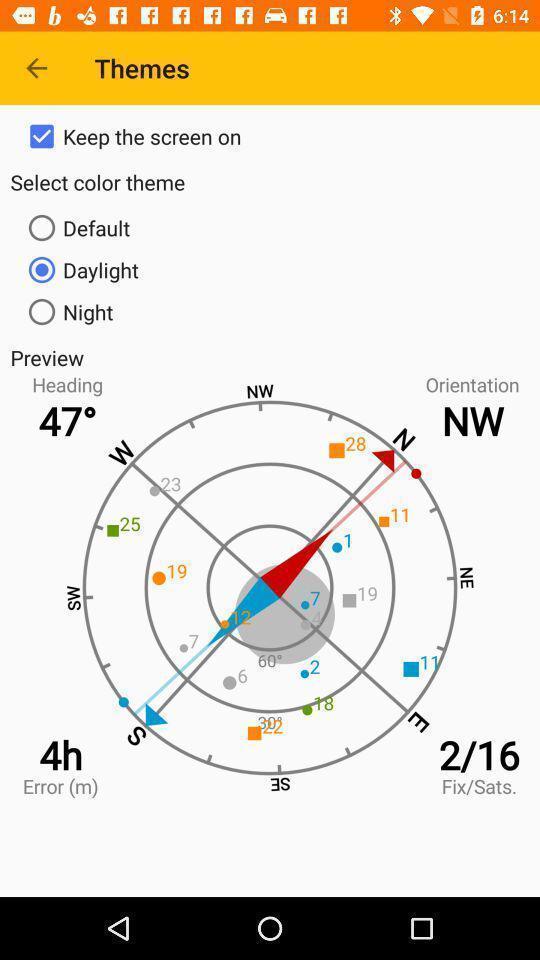Describe the key features of this screenshot. Screen displaying themes page. 